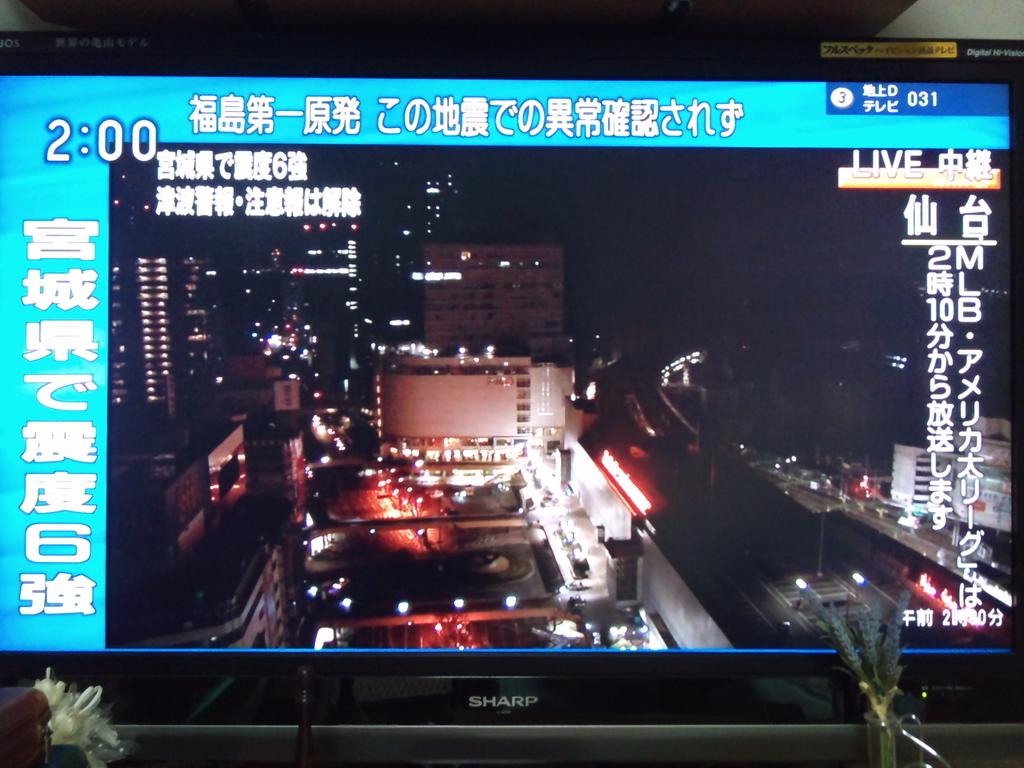What brand of tv is this?
Make the answer very short. Sharp. 